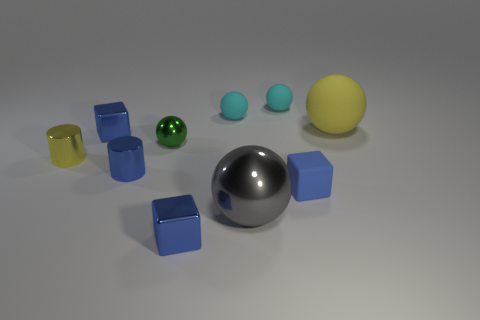Subtract all blue metal blocks. How many blocks are left? 1 Subtract 2 blocks. How many blocks are left? 1 Subtract all gray balls. Subtract all gray cylinders. How many balls are left? 4 Subtract all cyan cubes. How many green spheres are left? 1 Subtract all tiny blue things. Subtract all tiny metal balls. How many objects are left? 5 Add 2 tiny blocks. How many tiny blocks are left? 5 Add 1 red objects. How many red objects exist? 1 Subtract all yellow cylinders. How many cylinders are left? 1 Subtract 0 purple spheres. How many objects are left? 10 Subtract all cubes. How many objects are left? 7 